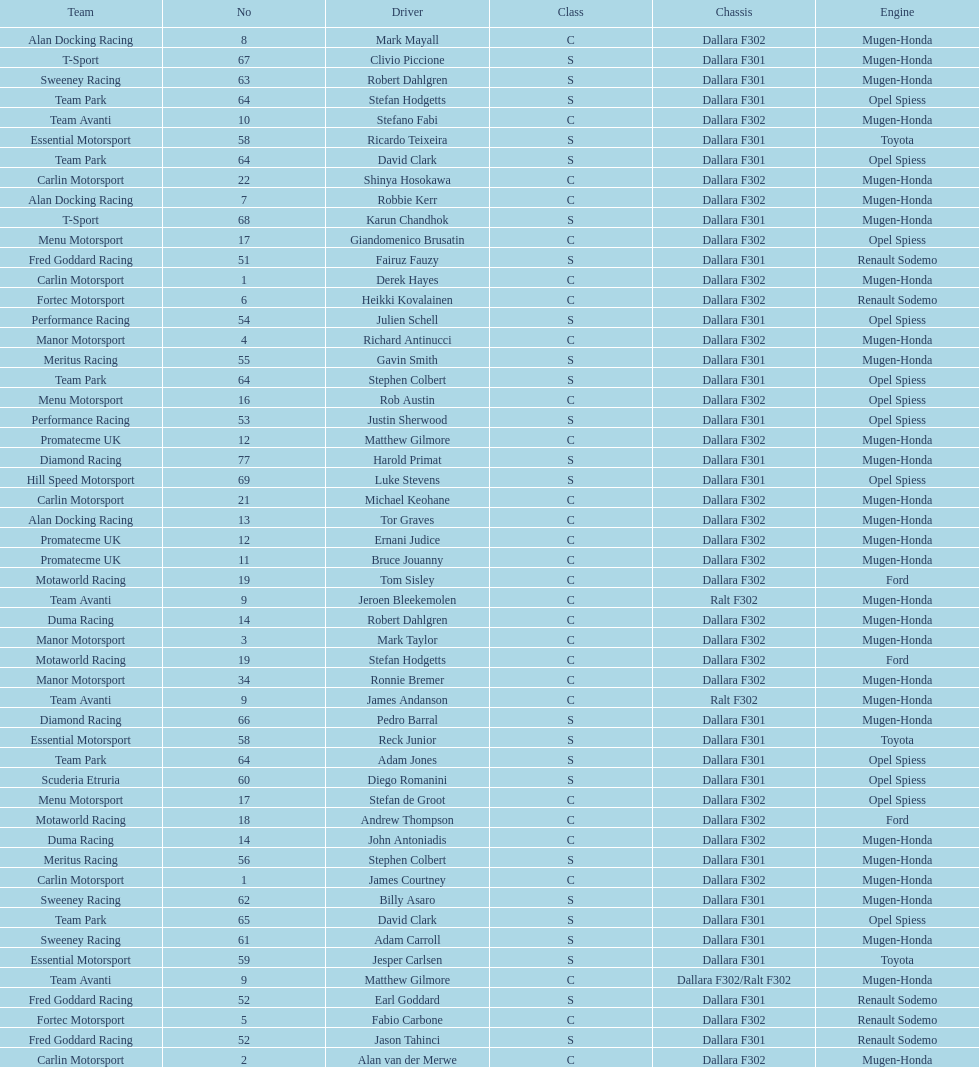Who had more drivers, team avanti or motaworld racing? Team Avanti. 